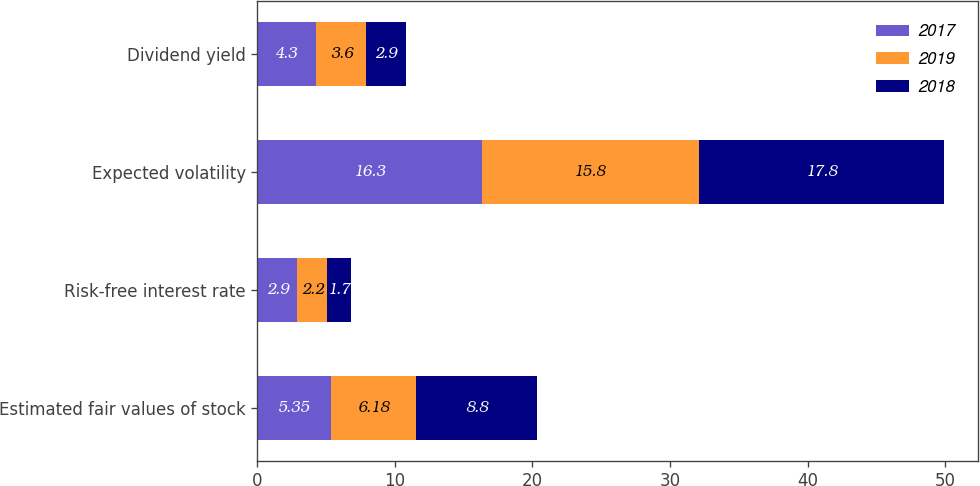Convert chart. <chart><loc_0><loc_0><loc_500><loc_500><stacked_bar_chart><ecel><fcel>Estimated fair values of stock<fcel>Risk-free interest rate<fcel>Expected volatility<fcel>Dividend yield<nl><fcel>2017<fcel>5.35<fcel>2.9<fcel>16.3<fcel>4.3<nl><fcel>2019<fcel>6.18<fcel>2.2<fcel>15.8<fcel>3.6<nl><fcel>2018<fcel>8.8<fcel>1.7<fcel>17.8<fcel>2.9<nl></chart> 